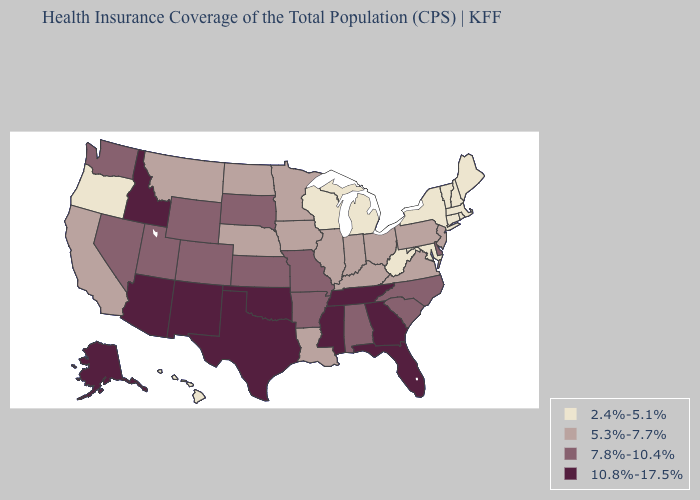Name the states that have a value in the range 10.8%-17.5%?
Keep it brief. Alaska, Arizona, Florida, Georgia, Idaho, Mississippi, New Mexico, Oklahoma, Tennessee, Texas. Does California have the highest value in the West?
Give a very brief answer. No. Name the states that have a value in the range 7.8%-10.4%?
Give a very brief answer. Alabama, Arkansas, Colorado, Delaware, Kansas, Missouri, Nevada, North Carolina, South Carolina, South Dakota, Utah, Washington, Wyoming. Does the first symbol in the legend represent the smallest category?
Short answer required. Yes. Does the first symbol in the legend represent the smallest category?
Keep it brief. Yes. Name the states that have a value in the range 5.3%-7.7%?
Concise answer only. California, Illinois, Indiana, Iowa, Kentucky, Louisiana, Minnesota, Montana, Nebraska, New Jersey, North Dakota, Ohio, Pennsylvania, Virginia. Which states have the lowest value in the West?
Write a very short answer. Hawaii, Oregon. What is the highest value in the USA?
Answer briefly. 10.8%-17.5%. Does Arkansas have a lower value than Utah?
Short answer required. No. Name the states that have a value in the range 7.8%-10.4%?
Concise answer only. Alabama, Arkansas, Colorado, Delaware, Kansas, Missouri, Nevada, North Carolina, South Carolina, South Dakota, Utah, Washington, Wyoming. Name the states that have a value in the range 5.3%-7.7%?
Give a very brief answer. California, Illinois, Indiana, Iowa, Kentucky, Louisiana, Minnesota, Montana, Nebraska, New Jersey, North Dakota, Ohio, Pennsylvania, Virginia. Name the states that have a value in the range 7.8%-10.4%?
Give a very brief answer. Alabama, Arkansas, Colorado, Delaware, Kansas, Missouri, Nevada, North Carolina, South Carolina, South Dakota, Utah, Washington, Wyoming. How many symbols are there in the legend?
Keep it brief. 4. Which states have the highest value in the USA?
Answer briefly. Alaska, Arizona, Florida, Georgia, Idaho, Mississippi, New Mexico, Oklahoma, Tennessee, Texas. 